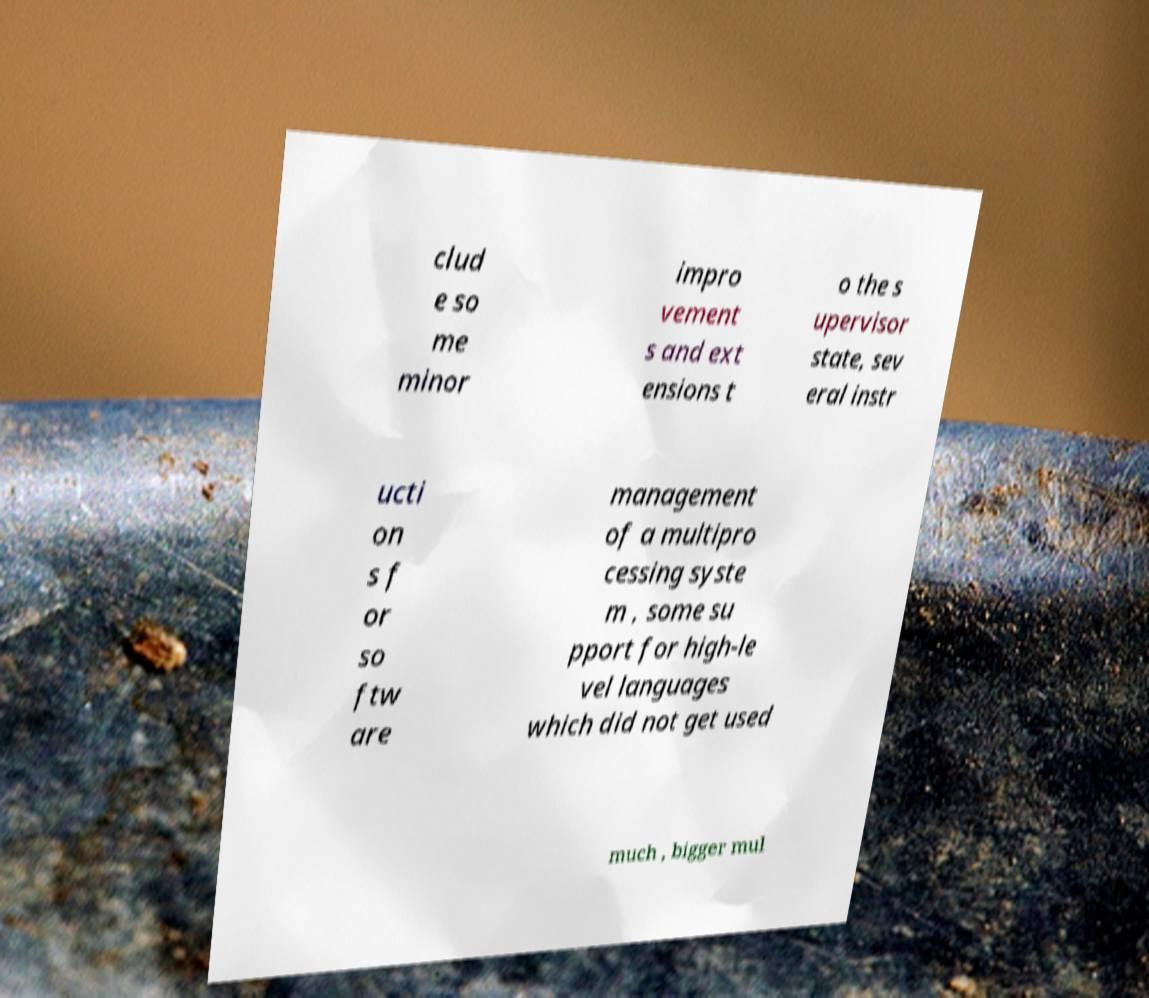Please identify and transcribe the text found in this image. clud e so me minor impro vement s and ext ensions t o the s upervisor state, sev eral instr ucti on s f or so ftw are management of a multipro cessing syste m , some su pport for high-le vel languages which did not get used much , bigger mul 